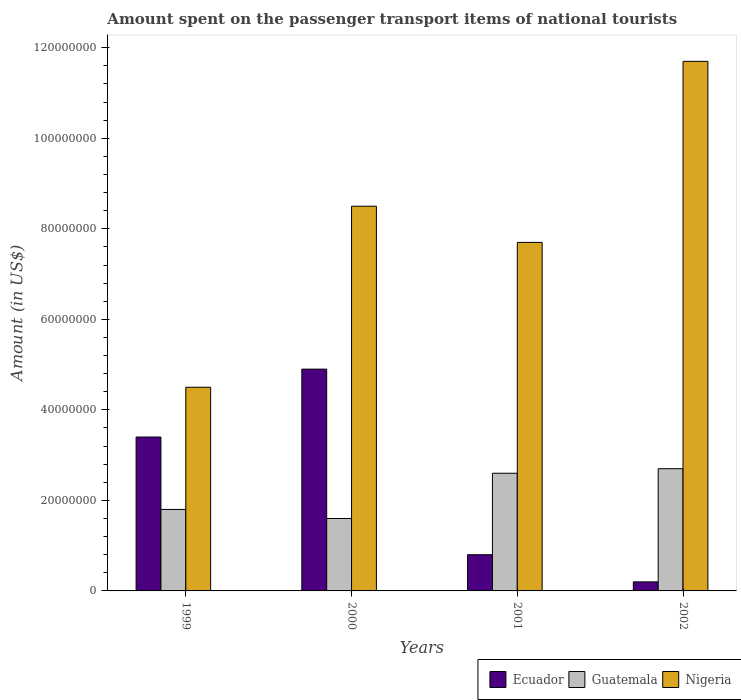Are the number of bars per tick equal to the number of legend labels?
Offer a very short reply. Yes. What is the amount spent on the passenger transport items of national tourists in Ecuador in 2001?
Provide a short and direct response. 8.00e+06. Across all years, what is the maximum amount spent on the passenger transport items of national tourists in Ecuador?
Ensure brevity in your answer.  4.90e+07. Across all years, what is the minimum amount spent on the passenger transport items of national tourists in Nigeria?
Make the answer very short. 4.50e+07. In which year was the amount spent on the passenger transport items of national tourists in Ecuador minimum?
Offer a very short reply. 2002. What is the total amount spent on the passenger transport items of national tourists in Ecuador in the graph?
Offer a terse response. 9.30e+07. What is the difference between the amount spent on the passenger transport items of national tourists in Guatemala in 1999 and that in 2000?
Provide a short and direct response. 2.00e+06. What is the difference between the amount spent on the passenger transport items of national tourists in Ecuador in 2001 and the amount spent on the passenger transport items of national tourists in Nigeria in 2002?
Provide a short and direct response. -1.09e+08. What is the average amount spent on the passenger transport items of national tourists in Guatemala per year?
Offer a very short reply. 2.18e+07. In the year 2001, what is the difference between the amount spent on the passenger transport items of national tourists in Guatemala and amount spent on the passenger transport items of national tourists in Ecuador?
Your response must be concise. 1.80e+07. In how many years, is the amount spent on the passenger transport items of national tourists in Ecuador greater than 80000000 US$?
Your answer should be compact. 0. What is the ratio of the amount spent on the passenger transport items of national tourists in Guatemala in 2000 to that in 2002?
Provide a short and direct response. 0.59. Is the difference between the amount spent on the passenger transport items of national tourists in Guatemala in 1999 and 2001 greater than the difference between the amount spent on the passenger transport items of national tourists in Ecuador in 1999 and 2001?
Your answer should be compact. No. What is the difference between the highest and the second highest amount spent on the passenger transport items of national tourists in Guatemala?
Provide a succinct answer. 1.00e+06. What is the difference between the highest and the lowest amount spent on the passenger transport items of national tourists in Guatemala?
Give a very brief answer. 1.10e+07. What does the 2nd bar from the left in 2000 represents?
Ensure brevity in your answer.  Guatemala. What does the 2nd bar from the right in 2002 represents?
Your answer should be very brief. Guatemala. Is it the case that in every year, the sum of the amount spent on the passenger transport items of national tourists in Ecuador and amount spent on the passenger transport items of national tourists in Nigeria is greater than the amount spent on the passenger transport items of national tourists in Guatemala?
Provide a short and direct response. Yes. How many bars are there?
Your answer should be compact. 12. Are all the bars in the graph horizontal?
Your response must be concise. No. How many years are there in the graph?
Provide a short and direct response. 4. Are the values on the major ticks of Y-axis written in scientific E-notation?
Keep it short and to the point. No. Does the graph contain grids?
Offer a terse response. No. Where does the legend appear in the graph?
Provide a short and direct response. Bottom right. How many legend labels are there?
Offer a terse response. 3. How are the legend labels stacked?
Give a very brief answer. Horizontal. What is the title of the graph?
Provide a succinct answer. Amount spent on the passenger transport items of national tourists. Does "Belize" appear as one of the legend labels in the graph?
Your answer should be very brief. No. What is the label or title of the X-axis?
Your response must be concise. Years. What is the Amount (in US$) in Ecuador in 1999?
Keep it short and to the point. 3.40e+07. What is the Amount (in US$) in Guatemala in 1999?
Keep it short and to the point. 1.80e+07. What is the Amount (in US$) in Nigeria in 1999?
Give a very brief answer. 4.50e+07. What is the Amount (in US$) of Ecuador in 2000?
Your answer should be compact. 4.90e+07. What is the Amount (in US$) in Guatemala in 2000?
Ensure brevity in your answer.  1.60e+07. What is the Amount (in US$) of Nigeria in 2000?
Your answer should be very brief. 8.50e+07. What is the Amount (in US$) in Guatemala in 2001?
Provide a succinct answer. 2.60e+07. What is the Amount (in US$) in Nigeria in 2001?
Offer a terse response. 7.70e+07. What is the Amount (in US$) of Ecuador in 2002?
Provide a short and direct response. 2.00e+06. What is the Amount (in US$) in Guatemala in 2002?
Give a very brief answer. 2.70e+07. What is the Amount (in US$) in Nigeria in 2002?
Provide a succinct answer. 1.17e+08. Across all years, what is the maximum Amount (in US$) of Ecuador?
Provide a succinct answer. 4.90e+07. Across all years, what is the maximum Amount (in US$) in Guatemala?
Keep it short and to the point. 2.70e+07. Across all years, what is the maximum Amount (in US$) in Nigeria?
Ensure brevity in your answer.  1.17e+08. Across all years, what is the minimum Amount (in US$) of Guatemala?
Provide a short and direct response. 1.60e+07. Across all years, what is the minimum Amount (in US$) of Nigeria?
Your answer should be compact. 4.50e+07. What is the total Amount (in US$) in Ecuador in the graph?
Your answer should be compact. 9.30e+07. What is the total Amount (in US$) in Guatemala in the graph?
Make the answer very short. 8.70e+07. What is the total Amount (in US$) in Nigeria in the graph?
Your answer should be compact. 3.24e+08. What is the difference between the Amount (in US$) of Ecuador in 1999 and that in 2000?
Your response must be concise. -1.50e+07. What is the difference between the Amount (in US$) in Nigeria in 1999 and that in 2000?
Ensure brevity in your answer.  -4.00e+07. What is the difference between the Amount (in US$) in Ecuador in 1999 and that in 2001?
Your answer should be compact. 2.60e+07. What is the difference between the Amount (in US$) of Guatemala in 1999 and that in 2001?
Your answer should be very brief. -8.00e+06. What is the difference between the Amount (in US$) of Nigeria in 1999 and that in 2001?
Your answer should be very brief. -3.20e+07. What is the difference between the Amount (in US$) in Ecuador in 1999 and that in 2002?
Make the answer very short. 3.20e+07. What is the difference between the Amount (in US$) of Guatemala in 1999 and that in 2002?
Offer a very short reply. -9.00e+06. What is the difference between the Amount (in US$) of Nigeria in 1999 and that in 2002?
Offer a terse response. -7.20e+07. What is the difference between the Amount (in US$) of Ecuador in 2000 and that in 2001?
Offer a terse response. 4.10e+07. What is the difference between the Amount (in US$) of Guatemala in 2000 and that in 2001?
Offer a very short reply. -1.00e+07. What is the difference between the Amount (in US$) of Nigeria in 2000 and that in 2001?
Offer a very short reply. 8.00e+06. What is the difference between the Amount (in US$) in Ecuador in 2000 and that in 2002?
Offer a very short reply. 4.70e+07. What is the difference between the Amount (in US$) of Guatemala in 2000 and that in 2002?
Give a very brief answer. -1.10e+07. What is the difference between the Amount (in US$) in Nigeria in 2000 and that in 2002?
Ensure brevity in your answer.  -3.20e+07. What is the difference between the Amount (in US$) of Ecuador in 2001 and that in 2002?
Offer a terse response. 6.00e+06. What is the difference between the Amount (in US$) of Guatemala in 2001 and that in 2002?
Make the answer very short. -1.00e+06. What is the difference between the Amount (in US$) of Nigeria in 2001 and that in 2002?
Offer a very short reply. -4.00e+07. What is the difference between the Amount (in US$) of Ecuador in 1999 and the Amount (in US$) of Guatemala in 2000?
Your answer should be compact. 1.80e+07. What is the difference between the Amount (in US$) of Ecuador in 1999 and the Amount (in US$) of Nigeria in 2000?
Your response must be concise. -5.10e+07. What is the difference between the Amount (in US$) of Guatemala in 1999 and the Amount (in US$) of Nigeria in 2000?
Keep it short and to the point. -6.70e+07. What is the difference between the Amount (in US$) of Ecuador in 1999 and the Amount (in US$) of Nigeria in 2001?
Your answer should be very brief. -4.30e+07. What is the difference between the Amount (in US$) in Guatemala in 1999 and the Amount (in US$) in Nigeria in 2001?
Give a very brief answer. -5.90e+07. What is the difference between the Amount (in US$) of Ecuador in 1999 and the Amount (in US$) of Nigeria in 2002?
Your answer should be very brief. -8.30e+07. What is the difference between the Amount (in US$) in Guatemala in 1999 and the Amount (in US$) in Nigeria in 2002?
Provide a succinct answer. -9.90e+07. What is the difference between the Amount (in US$) in Ecuador in 2000 and the Amount (in US$) in Guatemala in 2001?
Your answer should be compact. 2.30e+07. What is the difference between the Amount (in US$) of Ecuador in 2000 and the Amount (in US$) of Nigeria in 2001?
Your answer should be very brief. -2.80e+07. What is the difference between the Amount (in US$) in Guatemala in 2000 and the Amount (in US$) in Nigeria in 2001?
Ensure brevity in your answer.  -6.10e+07. What is the difference between the Amount (in US$) in Ecuador in 2000 and the Amount (in US$) in Guatemala in 2002?
Make the answer very short. 2.20e+07. What is the difference between the Amount (in US$) of Ecuador in 2000 and the Amount (in US$) of Nigeria in 2002?
Give a very brief answer. -6.80e+07. What is the difference between the Amount (in US$) of Guatemala in 2000 and the Amount (in US$) of Nigeria in 2002?
Make the answer very short. -1.01e+08. What is the difference between the Amount (in US$) of Ecuador in 2001 and the Amount (in US$) of Guatemala in 2002?
Provide a succinct answer. -1.90e+07. What is the difference between the Amount (in US$) in Ecuador in 2001 and the Amount (in US$) in Nigeria in 2002?
Your response must be concise. -1.09e+08. What is the difference between the Amount (in US$) of Guatemala in 2001 and the Amount (in US$) of Nigeria in 2002?
Keep it short and to the point. -9.10e+07. What is the average Amount (in US$) in Ecuador per year?
Your answer should be very brief. 2.32e+07. What is the average Amount (in US$) in Guatemala per year?
Provide a succinct answer. 2.18e+07. What is the average Amount (in US$) in Nigeria per year?
Your response must be concise. 8.10e+07. In the year 1999, what is the difference between the Amount (in US$) of Ecuador and Amount (in US$) of Guatemala?
Your answer should be very brief. 1.60e+07. In the year 1999, what is the difference between the Amount (in US$) in Ecuador and Amount (in US$) in Nigeria?
Keep it short and to the point. -1.10e+07. In the year 1999, what is the difference between the Amount (in US$) in Guatemala and Amount (in US$) in Nigeria?
Give a very brief answer. -2.70e+07. In the year 2000, what is the difference between the Amount (in US$) of Ecuador and Amount (in US$) of Guatemala?
Ensure brevity in your answer.  3.30e+07. In the year 2000, what is the difference between the Amount (in US$) of Ecuador and Amount (in US$) of Nigeria?
Provide a short and direct response. -3.60e+07. In the year 2000, what is the difference between the Amount (in US$) in Guatemala and Amount (in US$) in Nigeria?
Your answer should be very brief. -6.90e+07. In the year 2001, what is the difference between the Amount (in US$) of Ecuador and Amount (in US$) of Guatemala?
Offer a terse response. -1.80e+07. In the year 2001, what is the difference between the Amount (in US$) of Ecuador and Amount (in US$) of Nigeria?
Make the answer very short. -6.90e+07. In the year 2001, what is the difference between the Amount (in US$) of Guatemala and Amount (in US$) of Nigeria?
Your answer should be very brief. -5.10e+07. In the year 2002, what is the difference between the Amount (in US$) in Ecuador and Amount (in US$) in Guatemala?
Provide a short and direct response. -2.50e+07. In the year 2002, what is the difference between the Amount (in US$) of Ecuador and Amount (in US$) of Nigeria?
Your answer should be very brief. -1.15e+08. In the year 2002, what is the difference between the Amount (in US$) of Guatemala and Amount (in US$) of Nigeria?
Offer a terse response. -9.00e+07. What is the ratio of the Amount (in US$) of Ecuador in 1999 to that in 2000?
Your response must be concise. 0.69. What is the ratio of the Amount (in US$) in Guatemala in 1999 to that in 2000?
Give a very brief answer. 1.12. What is the ratio of the Amount (in US$) of Nigeria in 1999 to that in 2000?
Make the answer very short. 0.53. What is the ratio of the Amount (in US$) in Ecuador in 1999 to that in 2001?
Ensure brevity in your answer.  4.25. What is the ratio of the Amount (in US$) of Guatemala in 1999 to that in 2001?
Your response must be concise. 0.69. What is the ratio of the Amount (in US$) in Nigeria in 1999 to that in 2001?
Ensure brevity in your answer.  0.58. What is the ratio of the Amount (in US$) in Ecuador in 1999 to that in 2002?
Your answer should be compact. 17. What is the ratio of the Amount (in US$) in Nigeria in 1999 to that in 2002?
Your answer should be compact. 0.38. What is the ratio of the Amount (in US$) in Ecuador in 2000 to that in 2001?
Your answer should be very brief. 6.12. What is the ratio of the Amount (in US$) in Guatemala in 2000 to that in 2001?
Make the answer very short. 0.62. What is the ratio of the Amount (in US$) in Nigeria in 2000 to that in 2001?
Provide a short and direct response. 1.1. What is the ratio of the Amount (in US$) in Guatemala in 2000 to that in 2002?
Your answer should be very brief. 0.59. What is the ratio of the Amount (in US$) of Nigeria in 2000 to that in 2002?
Your answer should be compact. 0.73. What is the ratio of the Amount (in US$) of Ecuador in 2001 to that in 2002?
Keep it short and to the point. 4. What is the ratio of the Amount (in US$) in Guatemala in 2001 to that in 2002?
Give a very brief answer. 0.96. What is the ratio of the Amount (in US$) of Nigeria in 2001 to that in 2002?
Your answer should be very brief. 0.66. What is the difference between the highest and the second highest Amount (in US$) in Ecuador?
Offer a very short reply. 1.50e+07. What is the difference between the highest and the second highest Amount (in US$) of Nigeria?
Provide a succinct answer. 3.20e+07. What is the difference between the highest and the lowest Amount (in US$) of Ecuador?
Your answer should be compact. 4.70e+07. What is the difference between the highest and the lowest Amount (in US$) of Guatemala?
Provide a succinct answer. 1.10e+07. What is the difference between the highest and the lowest Amount (in US$) of Nigeria?
Offer a terse response. 7.20e+07. 